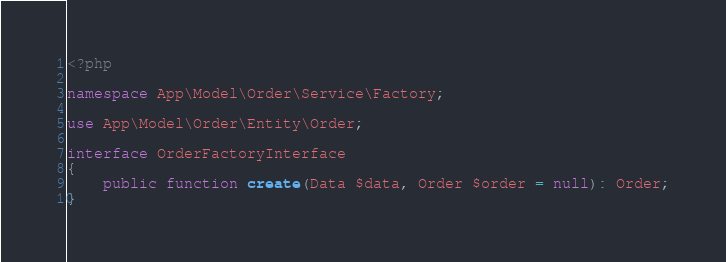<code> <loc_0><loc_0><loc_500><loc_500><_PHP_><?php

namespace App\Model\Order\Service\Factory;

use App\Model\Order\Entity\Order;

interface OrderFactoryInterface
{
    public function create(Data $data, Order $order = null): Order;
}
</code> 